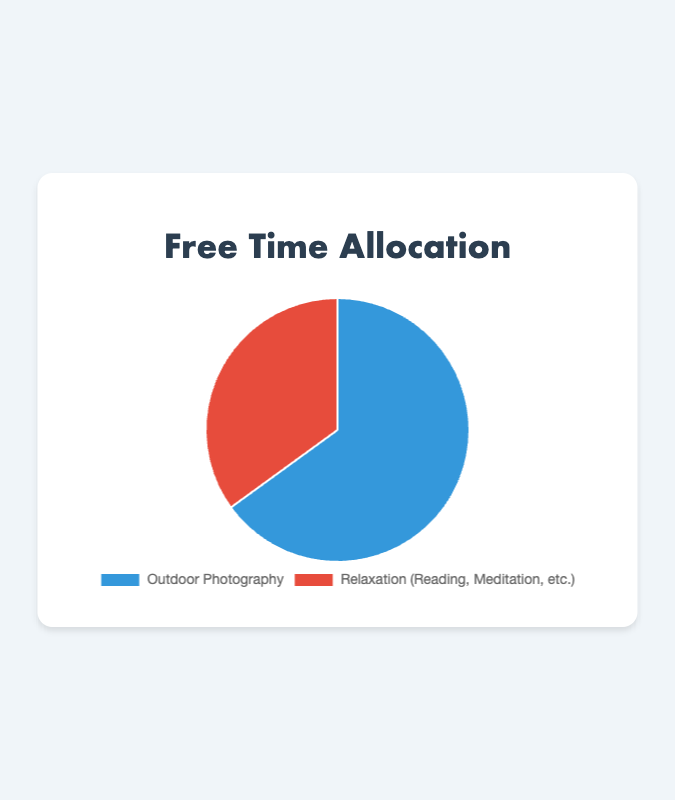How much more time is allocated to Outdoor Photography than Relaxation? Outdoor Photography takes up 65% and Relaxation takes up 35%. The difference is calculated as 65% - 35% = 30%.
Answer: 30% Which activity has a higher allocation of free time? By comparing percentages, Outdoor Photography has 65% while Relaxation has 35%. Therefore, Outdoor Photography has a higher allocation.
Answer: Outdoor Photography What proportion of free time is dedicated to non-Relaxation activities? The chart shows two categories, Outdoor Photography and Relaxation. Non-Relaxation activities encompass only Outdoor Photography, which is 65%.
Answer: 65% If free time was equally split between the two activities, what would be the difference from the current allocation for each activity? Equal split means 50% for each activity. Currently, Outdoor Photography has 65% and Relaxation has 35%. The difference for Outdoor Photography is 65% - 50% = 15%, and for Relaxation, it's 50% - 35% = 15%.
Answer: Outdoor Photography: 15%, Relaxation: 15% What is the ratio of time spent on Outdoor Photography to Relaxation? The time spent on Outdoor Photography is 65%, and on Relaxation is 35%. The ratio is given by 65/35 which simplifies to 13/7.
Answer: 13:7 Which color corresponds to Outdoor Photography in the pie chart? From the chart, Outdoor Photography is colored blue, as indicated by the background color settings.
Answer: Blue If the total available free time is 20 hours, how many hours are allocated to Relaxation? Relaxation takes up 35% of the total free time. 35% of 20 hours is calculated as 0.35 * 20 = 7 hours.
Answer: 7 hours By how much does the share of Outdoor Photography exceed twice the share of Relaxation? Twice the share of Relaxation is 2 * 35% = 70%. Outdoor Photography takes up 65%. The difference is 70% - 65% = -5%.
Answer: -5% Determine the mean percentage allocation between the two activities. The percentages are 65% and 35%. The mean is calculated as (65% + 35%) / 2 = 100% / 2 = 50%.
Answer: 50% Is the percentage of time spent on Relaxation more than half of that on Outdoor Photography? Half of the time spent on Outdoor Photography is 65% / 2 = 32.5%. Relaxation is at 35%, which is more than 32.5%.
Answer: Yes 